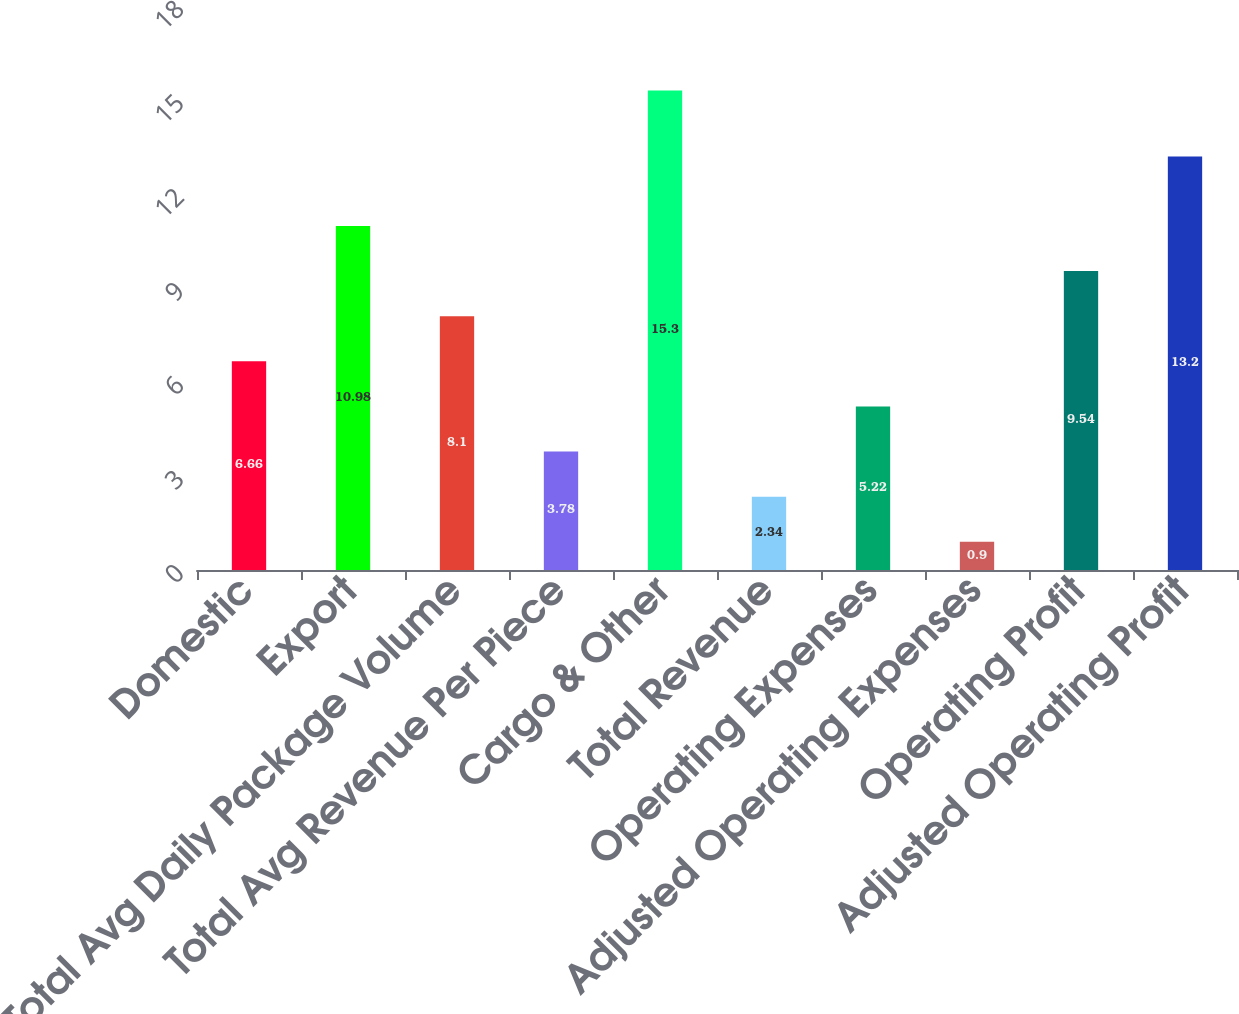Convert chart. <chart><loc_0><loc_0><loc_500><loc_500><bar_chart><fcel>Domestic<fcel>Export<fcel>Total Avg Daily Package Volume<fcel>Total Avg Revenue Per Piece<fcel>Cargo & Other<fcel>Total Revenue<fcel>Operating Expenses<fcel>Adjusted Operating Expenses<fcel>Operating Profit<fcel>Adjusted Operating Profit<nl><fcel>6.66<fcel>10.98<fcel>8.1<fcel>3.78<fcel>15.3<fcel>2.34<fcel>5.22<fcel>0.9<fcel>9.54<fcel>13.2<nl></chart> 